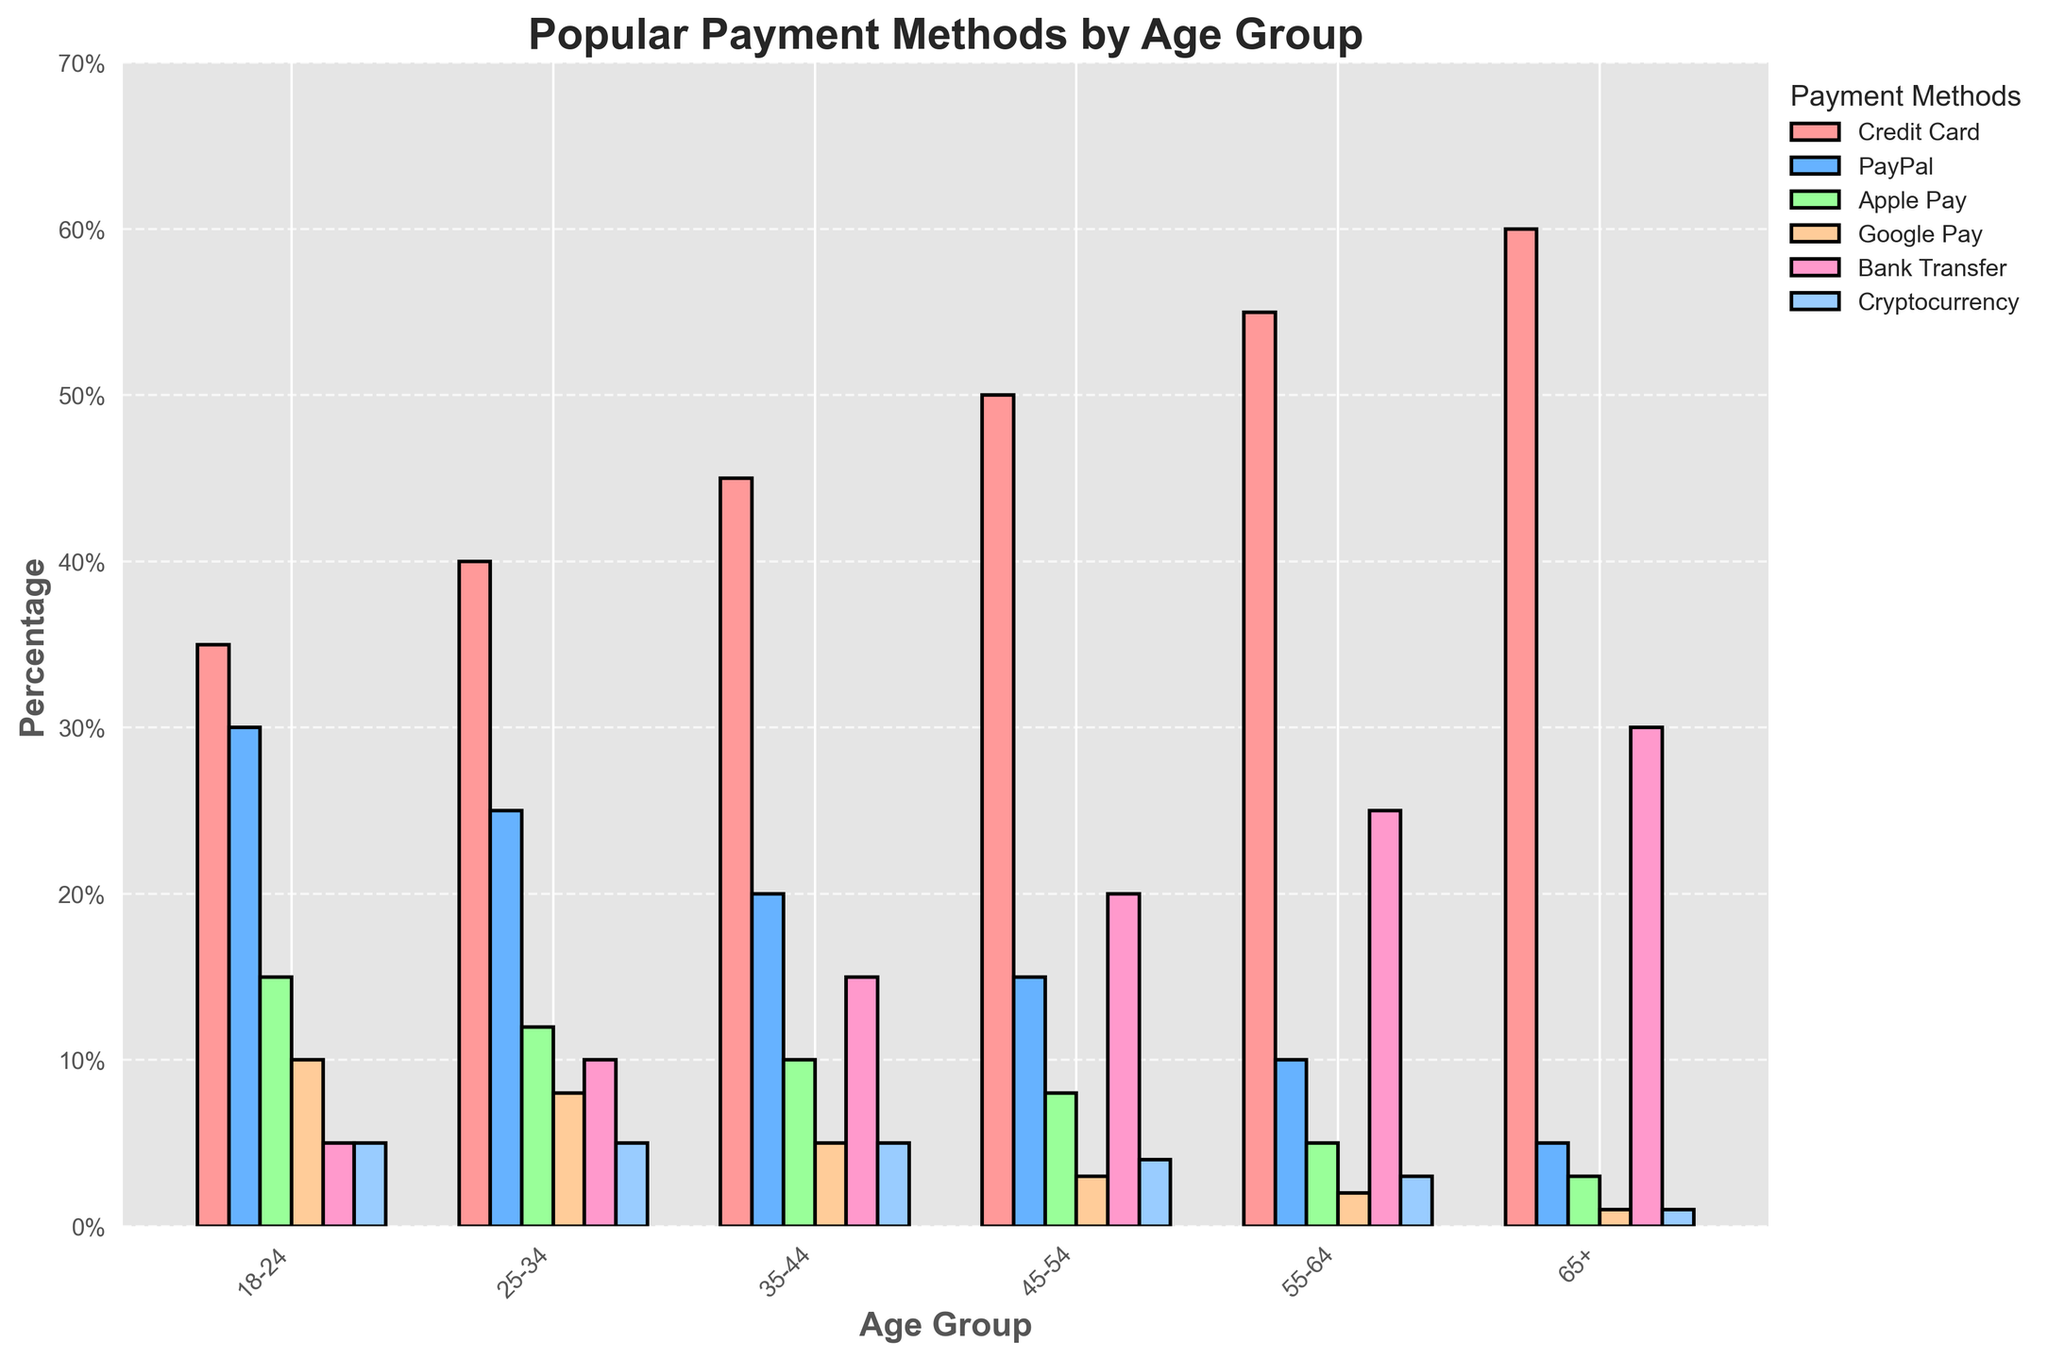What is the most popular payment method among shoppers aged 25-34? The tallest bar in the age group 25-34 corresponds to the Credit Card category, indicating it is the most popular payment method.
Answer: Credit Card Which age group has the highest percentage of Google Pay users? By scanning the bars corresponding to Google Pay across all age groups, it's clear that the 18-24 age group has the highest bar.
Answer: 18-24 What is the difference in the usage percentage of Bank Transfer between the 35-44 and 65+ age groups? The bar for Bank Transfer in the 35-44 age group is at 15%, while in the 65+ age group, it is at 30%. The difference is 30% - 15% = 15%.
Answer: 15% Which payment method is least popular among aged 55-64? The shortest bar in the 55-64 age group corresponds to Cryptocurrency, indicating it is the least popular method.
Answer: Cryptocurrency How does the usage of PayPal compare between the youngest (18-24) and oldest (65+) age groups? Observing the PayPal bars, the youngest age group (18-24) shows a 30% usage while the oldest group (65+) shows 5% usage. 30% is higher than 5% indicating PayPal is much more popular among the younger group.
Answer: PayPal is much more popular among the youngest group What is the combined percentage for Credit Card and Bank Transfer usage among shoppers aged 45-54? The Credit Card usage is 50% and the Bank Transfer usage is 20% in the 45-54 age group. The combined percentage is 50% + 20% = 70%.
Answer: 70% What is the least popular payment method overall and how can you tell? By scanning the shortest bars across all categories and age groups, the shortest bars belong to Cryptocurrency, often appearing as the smallest percentage across all groups.
Answer: Cryptocurrency How much more popular is Apple Pay among shoppers aged 18-24 compared to those aged 55-64? The bar for Apple Pay in the 18-24 age group is at 15%, while in the 55-64 age group, it is at 5%. The difference is 15% - 5% = 10%.
Answer: 10% Which age group has the greatest diversity in payment method usage percentages? The age group 18-24 has values that range across a wider spectrum from 5% to 35%, indicating the greatest diversity in their payment method preferences.
Answer: 18-24 What is the average percentage of PayPal usage across all age groups? The usage percentages are 30%, 25%, 20%, 15%, 10%, and 5%. Summing these gives 105%, and dividing by the 6 age groups gives an average of 105% / 6 = 17.5%.
Answer: 17.5% 